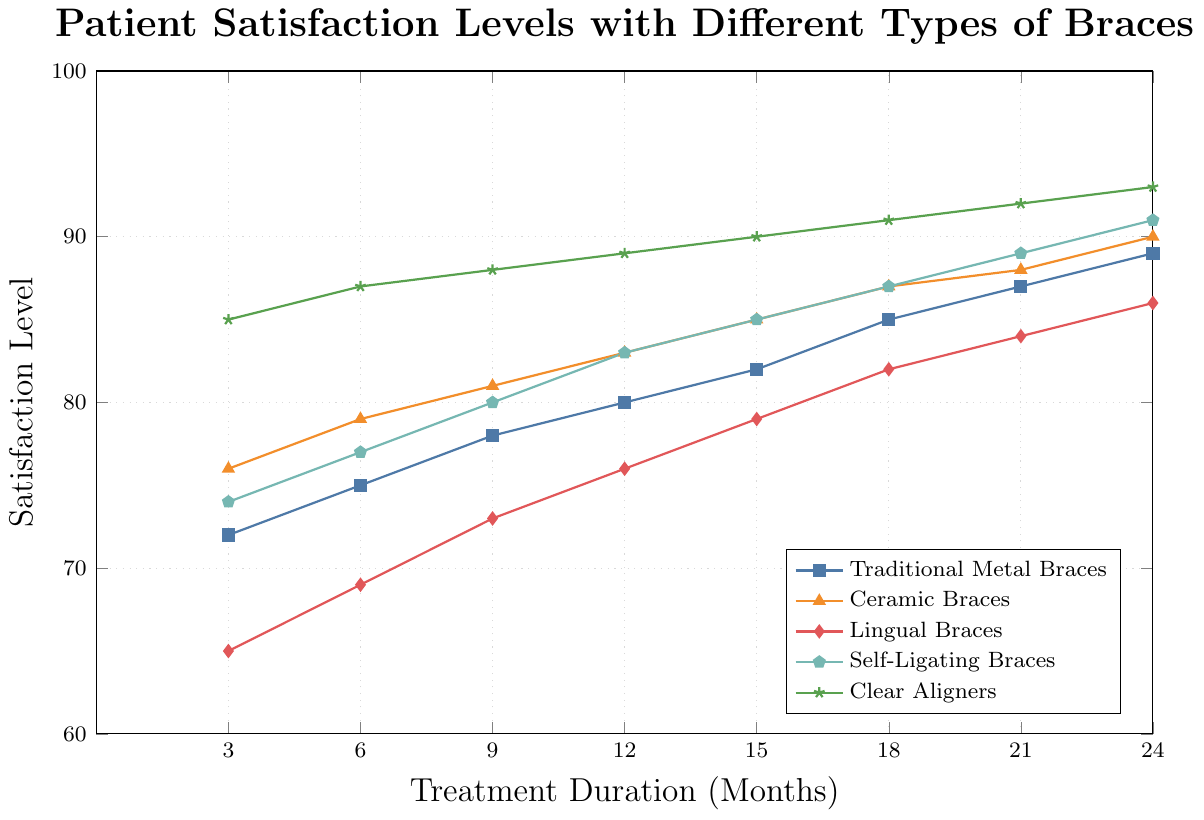Which type of braces has the highest patient satisfaction level at 3 months? At 3 months, the highest value on the y-axis corresponds to Clear Aligners with a level of 85.
Answer: Clear Aligners How much does the satisfaction level for Traditional Metal Braces increase from 3 months to 24 months? The satisfaction level at 3 months for Traditional Metal Braces is 72, and at 24 months it is 89. The increase is 89 - 72 = 17.
Answer: 17 Which type of braces shows the most consistent increase in satisfaction level over the treatment period? By examining the slope of each line, Clear Aligners show a consistent and steady increase in satisfaction level throughout the treatment duration.
Answer: Clear Aligners At 12 months, how do Ceramic Braces compare to Self-Ligating Braces in terms of patient satisfaction? At 12 months, the satisfaction level for Ceramic Braces is 83 and for Self-Ligating Braces is 83. The levels are identical.
Answer: They are equal What is the difference in patient satisfaction between Lingual Braces and Ceramic Braces at 24 months? At 24 months, Lingual Braces have a satisfaction level of 86, whereas Ceramic Braces have a level of 90. The difference is 90 - 86 = 4.
Answer: 4 Which type of braces has the lowest initial satisfaction level, and what is that level? By comparing the satisfaction levels at 3 months, Lingual Braces have the lowest initial satisfaction level at 65.
Answer: Lingual Braces, 65 What is the average satisfaction level for Self-Ligating Braces over the entire treatment period? The satisfaction levels for Self-Ligating Braces are 74, 77, 80, 83, 85, 87, 89, 91. Summing them gives 666. There are 8 values, so the average is 666 / 8 = 83.25.
Answer: 83.25 During the first 6 months, which type of braces experiences the fastest increase in patient satisfaction? From 3 months to 6 months, Clear Aligners increase by 2 points (85 to 87), which is the highest increase compared to other types.
Answer: Clear Aligners By how many satisfaction points does Ceramic Braces' satisfaction level change between 18 and 24 months? At 18 months, the satisfaction level for Ceramic Braces is 87. At 24 months, it is 90. The change is 90 - 87 = 3 points.
Answer: 3 